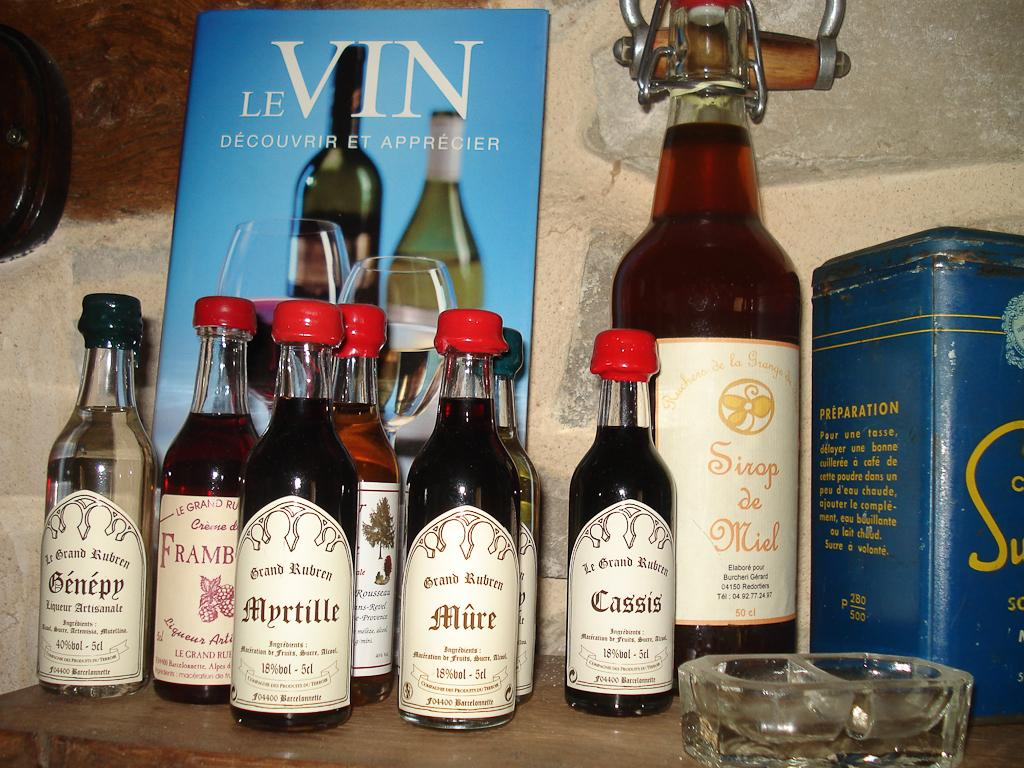<image>
Summarize the visual content of the image. A book titled LeVin is propped up behind some bottles. 